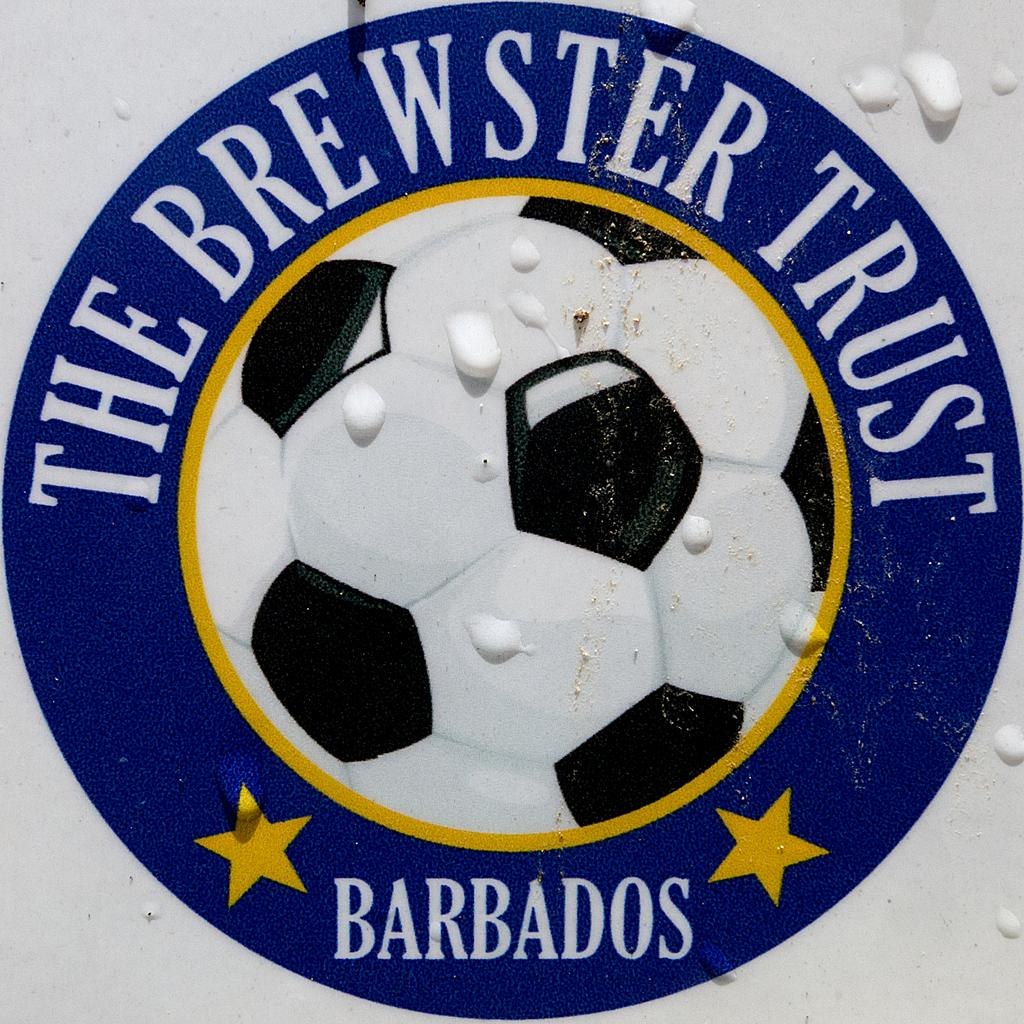What is the main subject of the image? The main subject of the image is a football logo. Are there any words present in the image? Yes, there are words written in the image. How many stars are in the image? There are 2 stars in the image. What type of stone is being used to make a wish in the image? There is no stone or wish-making activity present in the image. What kind of lumber is visible in the image? There is no lumber present in the image. 